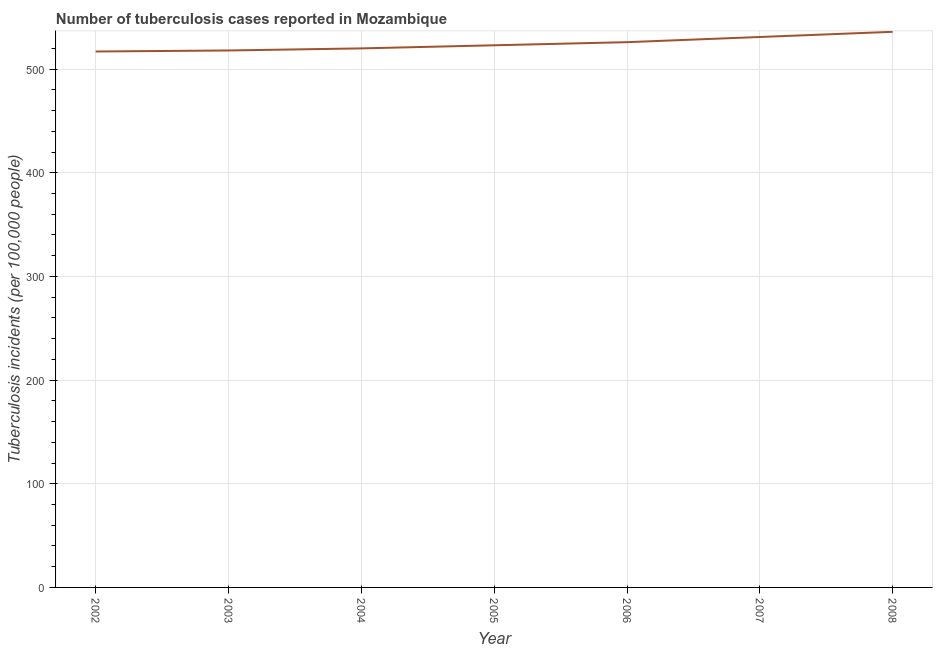What is the number of tuberculosis incidents in 2008?
Make the answer very short. 536. Across all years, what is the maximum number of tuberculosis incidents?
Provide a short and direct response. 536. Across all years, what is the minimum number of tuberculosis incidents?
Make the answer very short. 517. What is the sum of the number of tuberculosis incidents?
Provide a succinct answer. 3671. What is the difference between the number of tuberculosis incidents in 2005 and 2006?
Ensure brevity in your answer.  -3. What is the average number of tuberculosis incidents per year?
Ensure brevity in your answer.  524.43. What is the median number of tuberculosis incidents?
Ensure brevity in your answer.  523. In how many years, is the number of tuberculosis incidents greater than 140 ?
Offer a very short reply. 7. Do a majority of the years between 2005 and 2008 (inclusive) have number of tuberculosis incidents greater than 60 ?
Your answer should be compact. Yes. What is the ratio of the number of tuberculosis incidents in 2003 to that in 2007?
Keep it short and to the point. 0.98. Is the difference between the number of tuberculosis incidents in 2004 and 2006 greater than the difference between any two years?
Ensure brevity in your answer.  No. What is the difference between the highest and the second highest number of tuberculosis incidents?
Provide a succinct answer. 5. What is the difference between the highest and the lowest number of tuberculosis incidents?
Offer a very short reply. 19. Does the number of tuberculosis incidents monotonically increase over the years?
Your answer should be compact. Yes. How many years are there in the graph?
Offer a very short reply. 7. What is the difference between two consecutive major ticks on the Y-axis?
Provide a short and direct response. 100. What is the title of the graph?
Your answer should be compact. Number of tuberculosis cases reported in Mozambique. What is the label or title of the X-axis?
Your answer should be compact. Year. What is the label or title of the Y-axis?
Offer a very short reply. Tuberculosis incidents (per 100,0 people). What is the Tuberculosis incidents (per 100,000 people) of 2002?
Keep it short and to the point. 517. What is the Tuberculosis incidents (per 100,000 people) in 2003?
Make the answer very short. 518. What is the Tuberculosis incidents (per 100,000 people) of 2004?
Your answer should be very brief. 520. What is the Tuberculosis incidents (per 100,000 people) in 2005?
Offer a very short reply. 523. What is the Tuberculosis incidents (per 100,000 people) in 2006?
Provide a short and direct response. 526. What is the Tuberculosis incidents (per 100,000 people) in 2007?
Keep it short and to the point. 531. What is the Tuberculosis incidents (per 100,000 people) in 2008?
Give a very brief answer. 536. What is the difference between the Tuberculosis incidents (per 100,000 people) in 2002 and 2004?
Provide a short and direct response. -3. What is the difference between the Tuberculosis incidents (per 100,000 people) in 2002 and 2005?
Make the answer very short. -6. What is the difference between the Tuberculosis incidents (per 100,000 people) in 2002 and 2007?
Keep it short and to the point. -14. What is the difference between the Tuberculosis incidents (per 100,000 people) in 2003 and 2005?
Your response must be concise. -5. What is the difference between the Tuberculosis incidents (per 100,000 people) in 2004 and 2006?
Give a very brief answer. -6. What is the difference between the Tuberculosis incidents (per 100,000 people) in 2005 and 2008?
Your answer should be very brief. -13. What is the difference between the Tuberculosis incidents (per 100,000 people) in 2006 and 2007?
Make the answer very short. -5. What is the ratio of the Tuberculosis incidents (per 100,000 people) in 2002 to that in 2004?
Provide a succinct answer. 0.99. What is the ratio of the Tuberculosis incidents (per 100,000 people) in 2002 to that in 2005?
Offer a very short reply. 0.99. What is the ratio of the Tuberculosis incidents (per 100,000 people) in 2002 to that in 2006?
Your response must be concise. 0.98. What is the ratio of the Tuberculosis incidents (per 100,000 people) in 2002 to that in 2008?
Offer a very short reply. 0.96. What is the ratio of the Tuberculosis incidents (per 100,000 people) in 2003 to that in 2005?
Your response must be concise. 0.99. What is the ratio of the Tuberculosis incidents (per 100,000 people) in 2003 to that in 2006?
Provide a short and direct response. 0.98. What is the ratio of the Tuberculosis incidents (per 100,000 people) in 2003 to that in 2007?
Make the answer very short. 0.98. What is the ratio of the Tuberculosis incidents (per 100,000 people) in 2004 to that in 2005?
Keep it short and to the point. 0.99. What is the ratio of the Tuberculosis incidents (per 100,000 people) in 2004 to that in 2007?
Offer a very short reply. 0.98. What is the ratio of the Tuberculosis incidents (per 100,000 people) in 2005 to that in 2006?
Ensure brevity in your answer.  0.99. What is the ratio of the Tuberculosis incidents (per 100,000 people) in 2005 to that in 2007?
Provide a short and direct response. 0.98. What is the ratio of the Tuberculosis incidents (per 100,000 people) in 2005 to that in 2008?
Keep it short and to the point. 0.98. What is the ratio of the Tuberculosis incidents (per 100,000 people) in 2006 to that in 2007?
Offer a very short reply. 0.99. What is the ratio of the Tuberculosis incidents (per 100,000 people) in 2006 to that in 2008?
Give a very brief answer. 0.98. What is the ratio of the Tuberculosis incidents (per 100,000 people) in 2007 to that in 2008?
Keep it short and to the point. 0.99. 